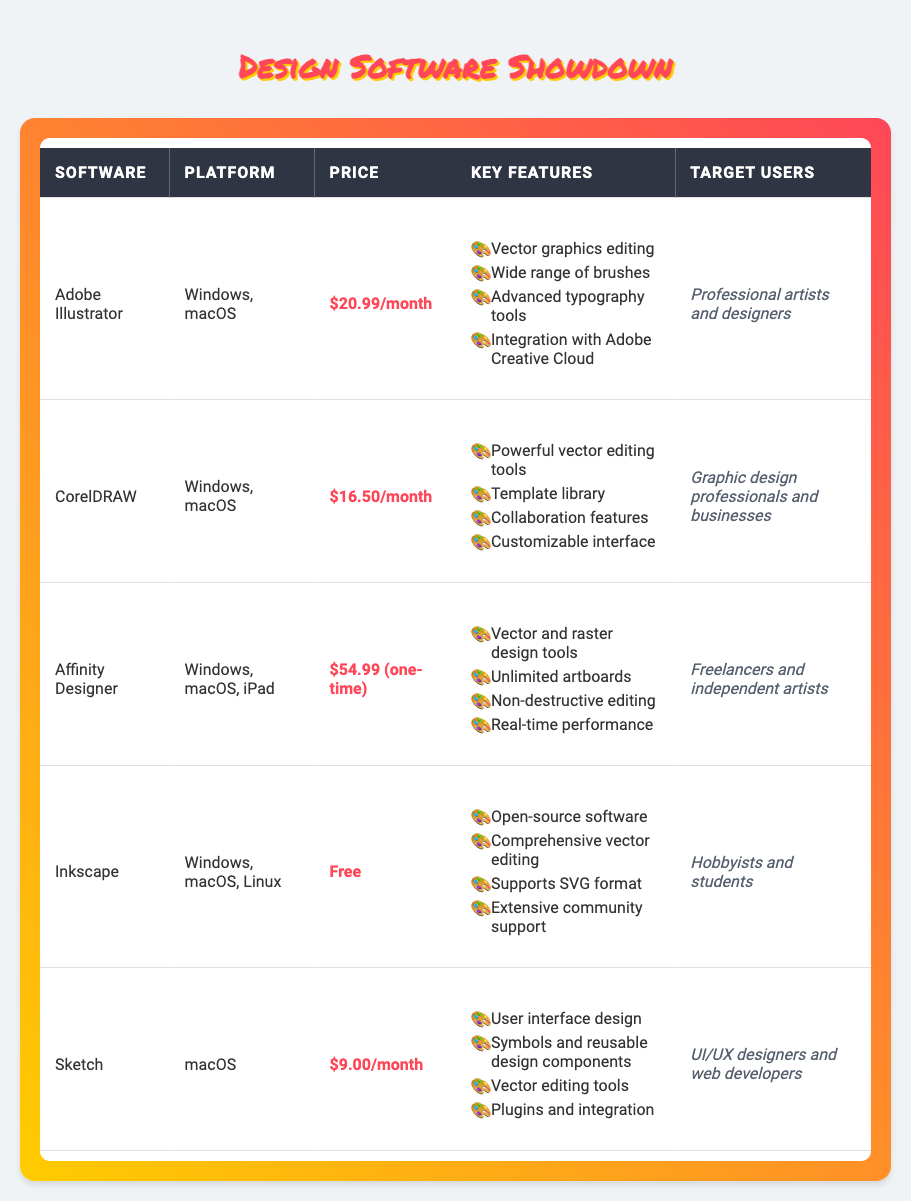What is the monthly price for Adobe Illustrator? Referring to the table under the "Price" column for Adobe Illustrator, the monthly price listed is $20.99.
Answer: $20.99 Which software is free? Looking through the table, Inkscape is the only software that has the price listed as Free.
Answer: Inkscape What are the key features of CorelDRAW? By checking the "Key Features" column for CorelDRAW, the features listed are: Powerful vector editing tools, Template library, Collaboration features, and Customizable interface.
Answer: Powerful vector editing tools, Template library, Collaboration features, Customizable interface Which software has the lowest monthly price? To find the lowest monthly price, we compare the monthly prices: Adobe Illustrator ($20.99), CorelDRAW ($16.50), Sketch ($9.00). The lowest among these is for Sketch at $9.00.
Answer: Sketch How much would it cost per year to use Affinity Designer? The one-time price for Affinity Designer is $54.99, so there is no ongoing monthly charge attributed to it; thus, it remains a single expense with no yearly cost to calculate.
Answer: $54.99 Is Adobe Illustrator intended for hobbyists? The target users for Adobe Illustrator are identified as professional artists and designers in the table, which indicates it is not specifically intended for hobbyists.
Answer: No How many software options are available for macOS? By scanning the table for the "Platform" column, we can find that Adobe Illustrator, CorelDRAW, Affinity Designer, Inkscape, and Sketch are all compatible with macOS. This totals to five software options.
Answer: Five If I use Sketch for 12 months, how much would I spend? Sketch's monthly price is $9.00. Thus for 12 months: 12 months * $9.00/month equals $108.00 total expenditure.
Answer: $108.00 Among the listed software, which is suitable for UI/UX designers? Referring to the "Target Users" column and looking for UI/UX designers, Sketch is explicitly mentioned as suitable for this group.
Answer: Sketch 